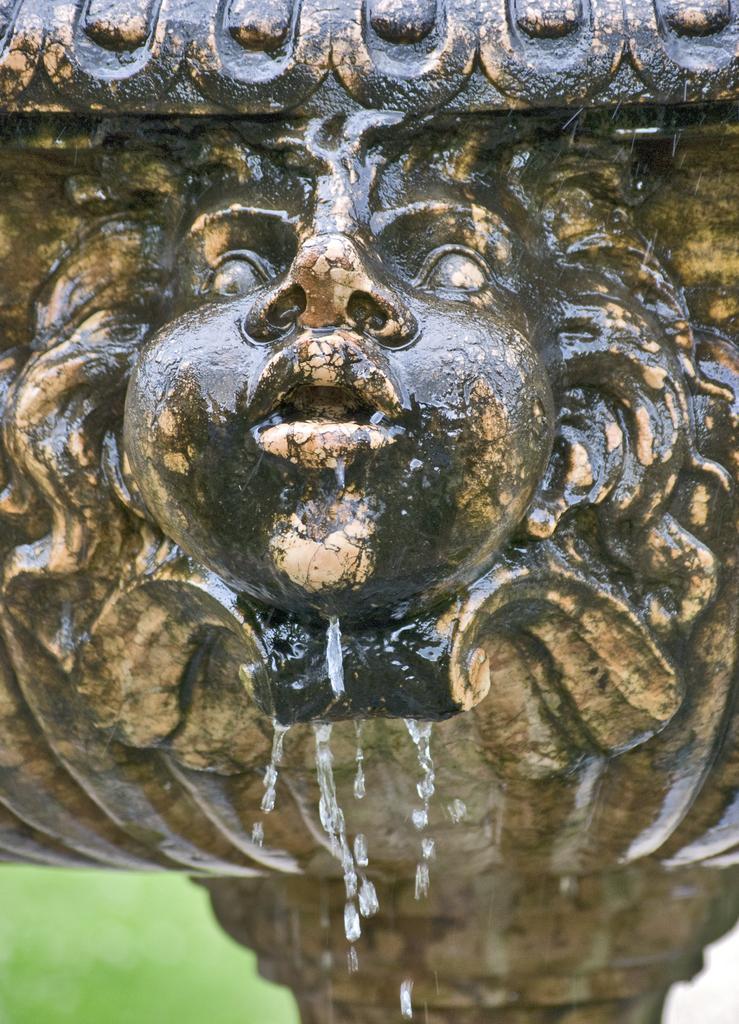Can you describe this image briefly? There is a sculpture and water is falling from it. 